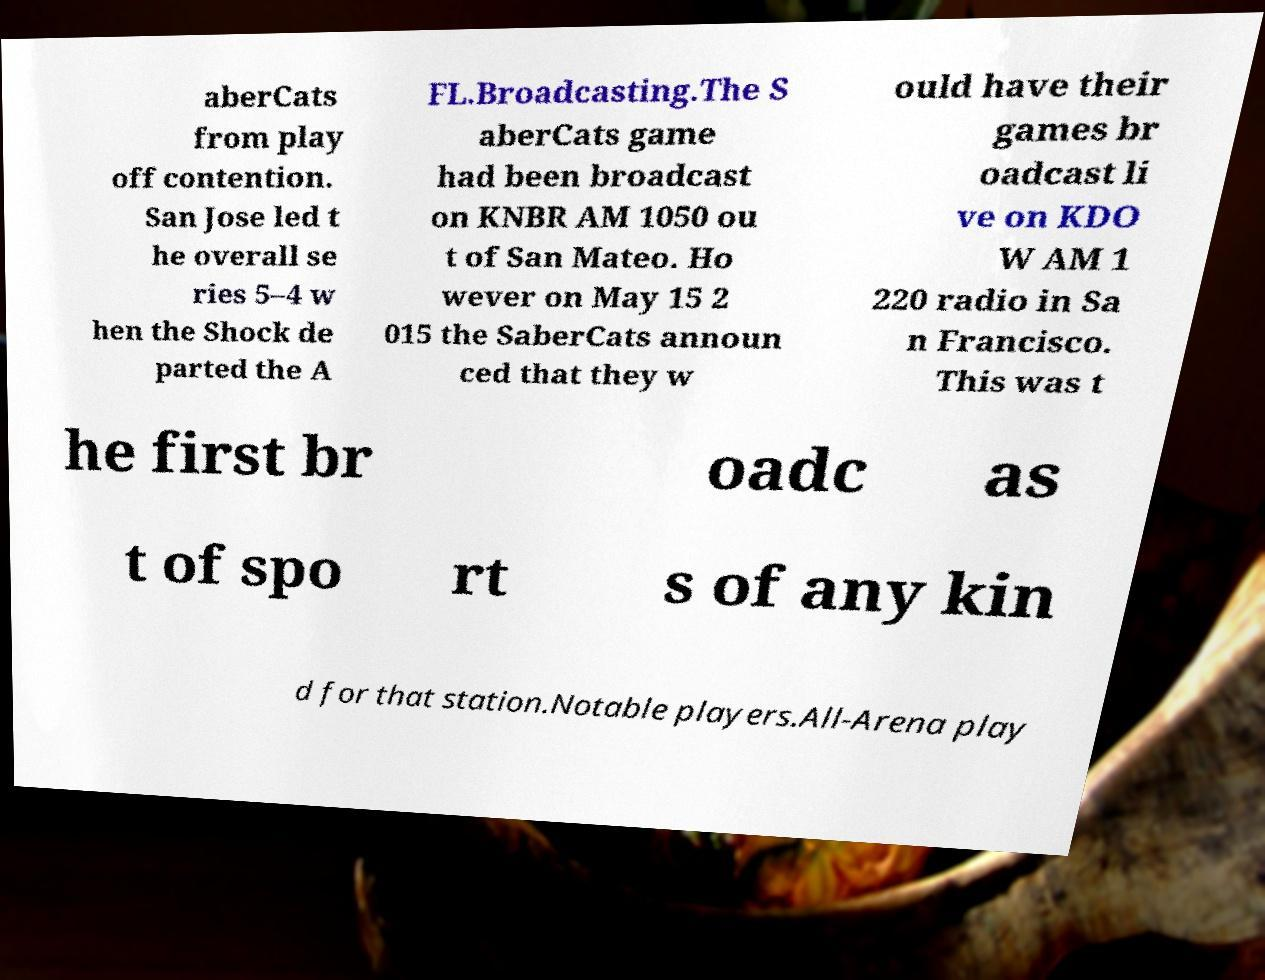Can you read and provide the text displayed in the image?This photo seems to have some interesting text. Can you extract and type it out for me? aberCats from play off contention. San Jose led t he overall se ries 5–4 w hen the Shock de parted the A FL.Broadcasting.The S aberCats game had been broadcast on KNBR AM 1050 ou t of San Mateo. Ho wever on May 15 2 015 the SaberCats announ ced that they w ould have their games br oadcast li ve on KDO W AM 1 220 radio in Sa n Francisco. This was t he first br oadc as t of spo rt s of any kin d for that station.Notable players.All-Arena play 